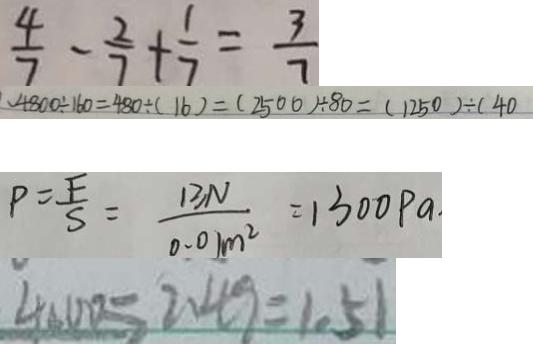<formula> <loc_0><loc_0><loc_500><loc_500>\frac { 4 } { 7 } - \frac { 2 } { 7 } + \frac { 1 } { 7 } = \frac { 3 } { 7 } 
 、 4 8 0 0 \div 1 6 0 = 4 8 0 \div ( 1 6 ) = ( 2 5 0 0 ) \div 8 0 = ( 1 2 5 0 ) \div ( 4 0 
 P = \frac { F } { S } = \frac { 1 3 N } { 0 . 0 1 m ^ { 2 } } = 1 3 0 0 P a 
 4 0 0 0 = 2 . 4 9 = 1 . 5 1</formula> 